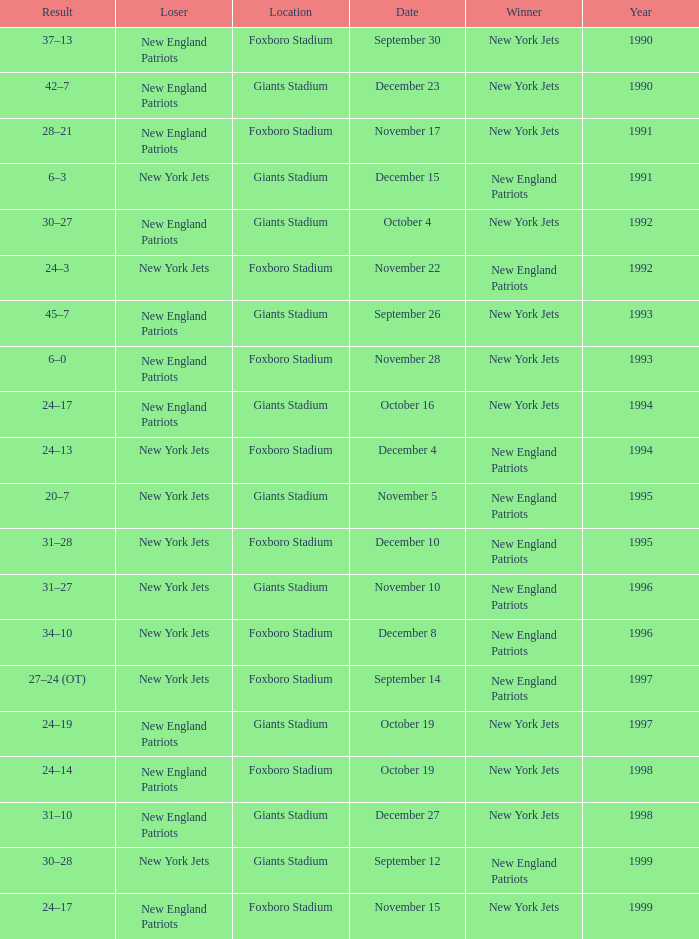What is the name of the Loser when the winner was new england patriots, and a Location of giants stadium, and a Result of 30–28? New York Jets. 